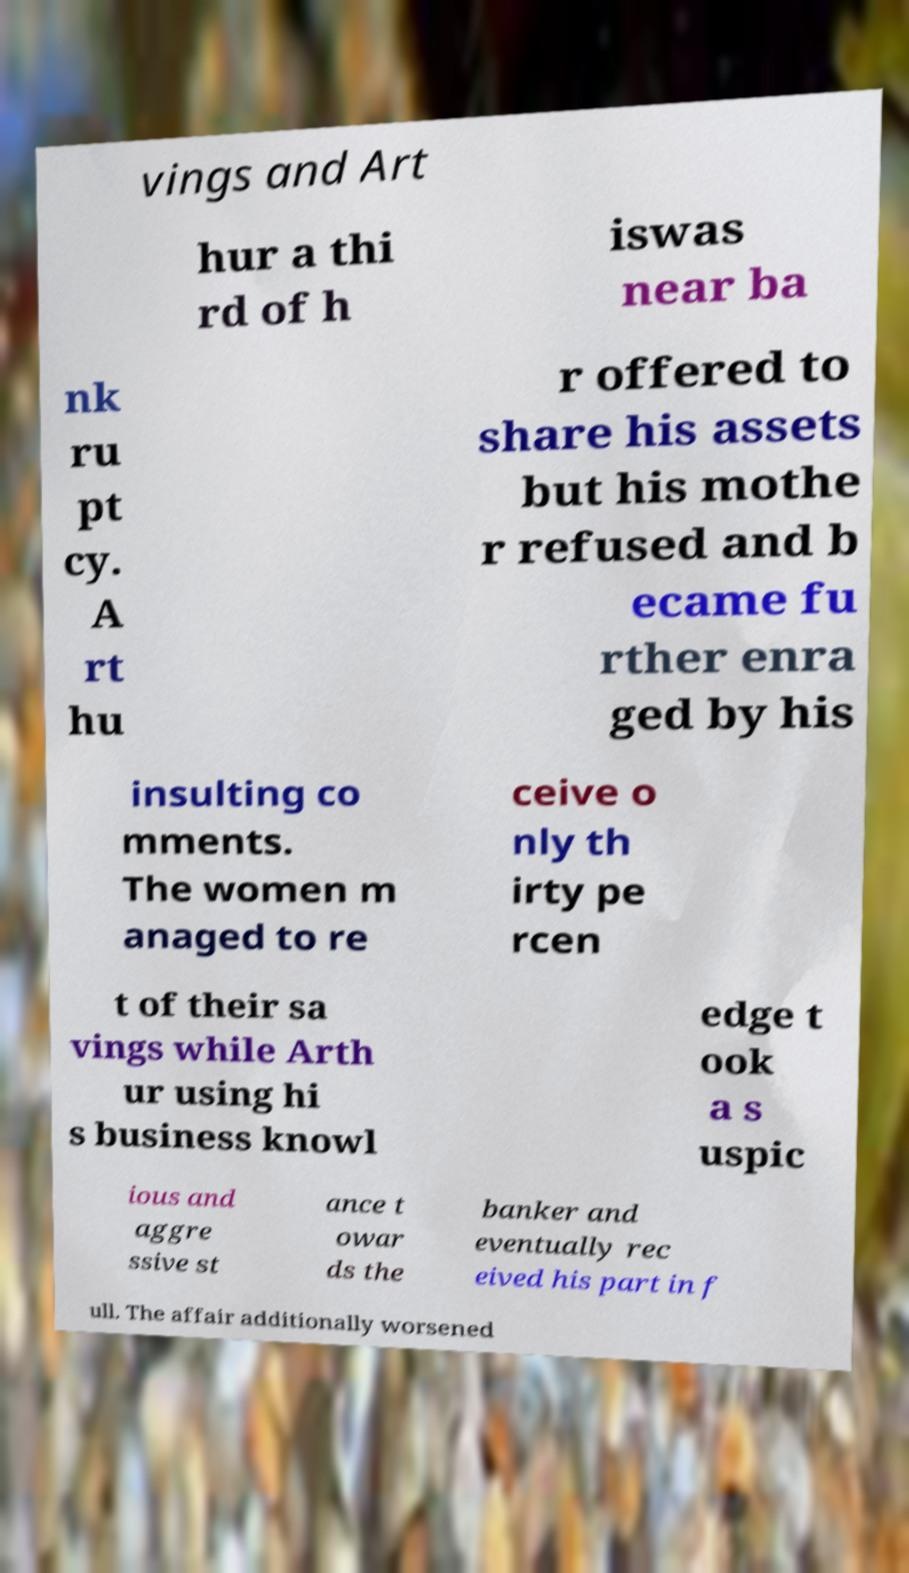Can you accurately transcribe the text from the provided image for me? vings and Art hur a thi rd of h iswas near ba nk ru pt cy. A rt hu r offered to share his assets but his mothe r refused and b ecame fu rther enra ged by his insulting co mments. The women m anaged to re ceive o nly th irty pe rcen t of their sa vings while Arth ur using hi s business knowl edge t ook a s uspic ious and aggre ssive st ance t owar ds the banker and eventually rec eived his part in f ull. The affair additionally worsened 